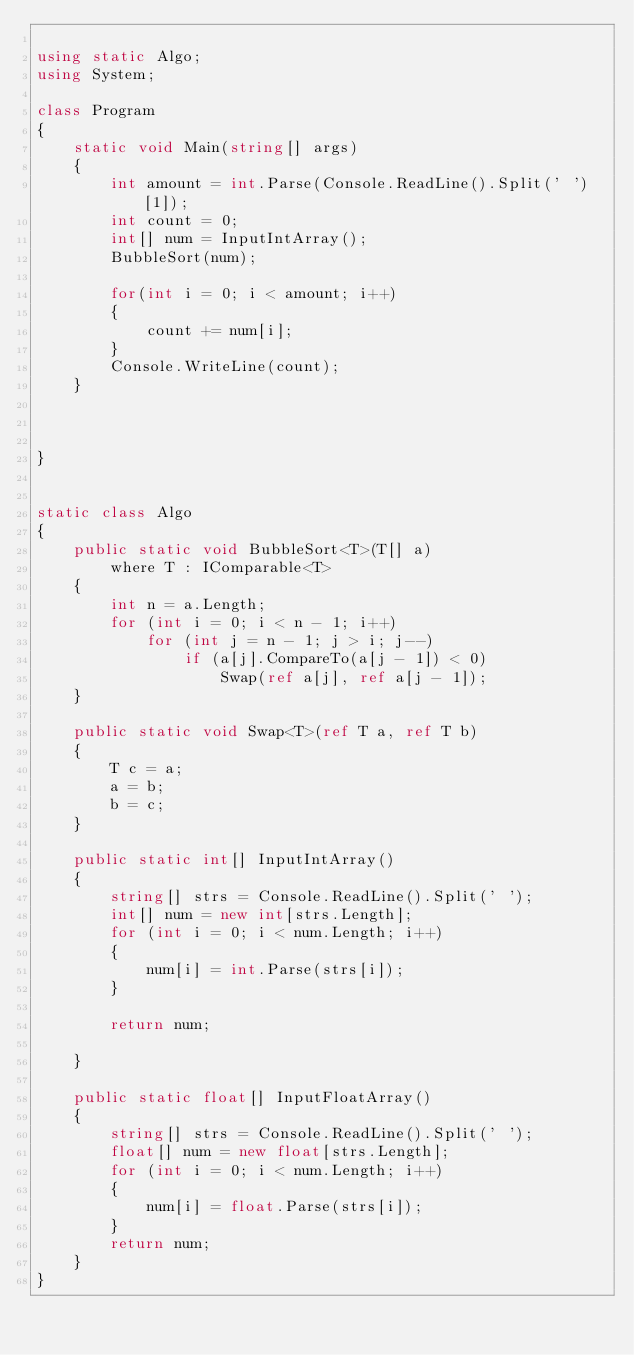<code> <loc_0><loc_0><loc_500><loc_500><_C#_>
using static Algo;
using System;

class Program
{
    static void Main(string[] args)
    {
        int amount = int.Parse(Console.ReadLine().Split(' ')[1]);
        int count = 0;
        int[] num = InputIntArray();
        BubbleSort(num);

        for(int i = 0; i < amount; i++)
        {
            count += num[i];
        }
        Console.WriteLine(count);
    }



}


static class Algo
{
    public static void BubbleSort<T>(T[] a)
        where T : IComparable<T>
    {
        int n = a.Length;
        for (int i = 0; i < n - 1; i++)
            for (int j = n - 1; j > i; j--)
                if (a[j].CompareTo(a[j - 1]) < 0)
                    Swap(ref a[j], ref a[j - 1]);
    }

    public static void Swap<T>(ref T a, ref T b)
    {
        T c = a;
        a = b;
        b = c;
    }

    public static int[] InputIntArray()
    {
        string[] strs = Console.ReadLine().Split(' ');
        int[] num = new int[strs.Length];
        for (int i = 0; i < num.Length; i++)
        {
            num[i] = int.Parse(strs[i]);
        }
       
        return num;
        
    }

    public static float[] InputFloatArray()
    {
        string[] strs = Console.ReadLine().Split(' ');
        float[] num = new float[strs.Length];
        for (int i = 0; i < num.Length; i++)
        {
            num[i] = float.Parse(strs[i]);
        }
        return num;
    }
}


</code> 